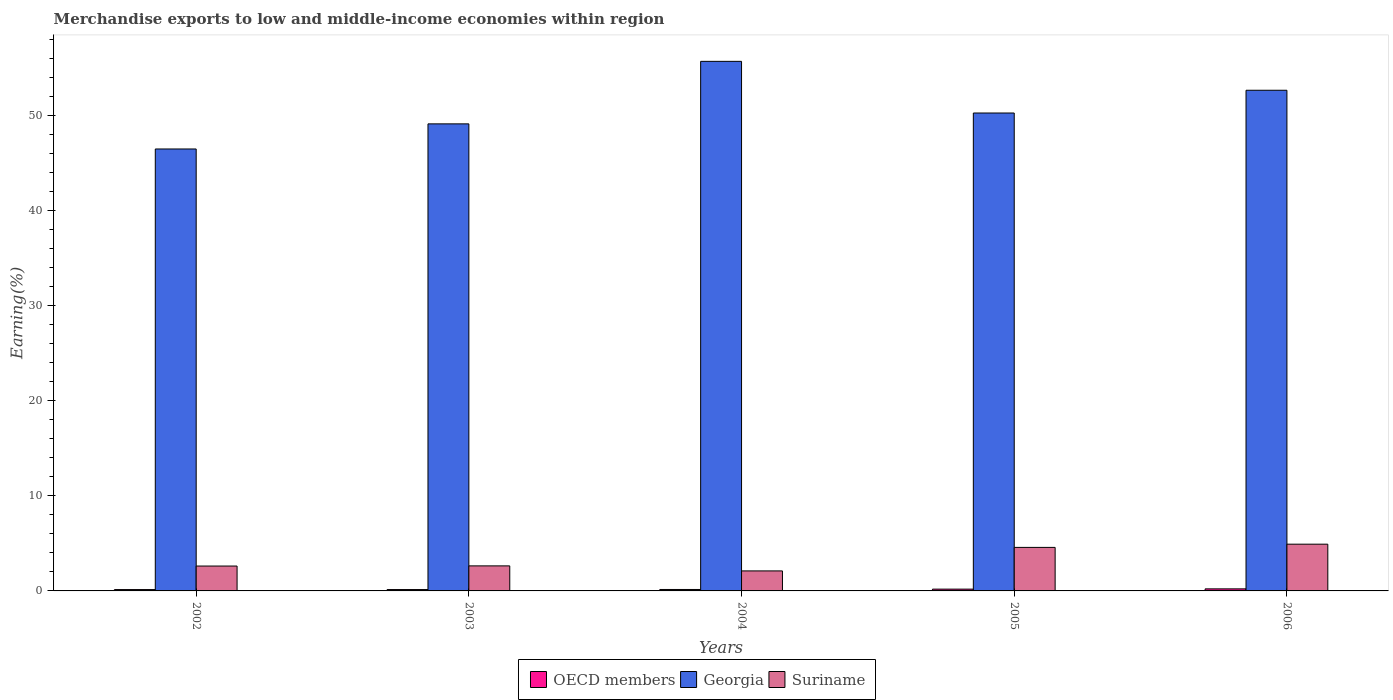Are the number of bars per tick equal to the number of legend labels?
Ensure brevity in your answer.  Yes. What is the percentage of amount earned from merchandise exports in OECD members in 2004?
Offer a terse response. 0.15. Across all years, what is the maximum percentage of amount earned from merchandise exports in Georgia?
Give a very brief answer. 55.66. Across all years, what is the minimum percentage of amount earned from merchandise exports in Georgia?
Your response must be concise. 46.45. In which year was the percentage of amount earned from merchandise exports in Suriname maximum?
Offer a very short reply. 2006. In which year was the percentage of amount earned from merchandise exports in Suriname minimum?
Your response must be concise. 2004. What is the total percentage of amount earned from merchandise exports in OECD members in the graph?
Make the answer very short. 0.84. What is the difference between the percentage of amount earned from merchandise exports in OECD members in 2002 and that in 2003?
Provide a succinct answer. -0. What is the difference between the percentage of amount earned from merchandise exports in Georgia in 2002 and the percentage of amount earned from merchandise exports in Suriname in 2004?
Give a very brief answer. 44.35. What is the average percentage of amount earned from merchandise exports in Suriname per year?
Make the answer very short. 3.37. In the year 2003, what is the difference between the percentage of amount earned from merchandise exports in OECD members and percentage of amount earned from merchandise exports in Suriname?
Ensure brevity in your answer.  -2.49. What is the ratio of the percentage of amount earned from merchandise exports in OECD members in 2002 to that in 2006?
Ensure brevity in your answer.  0.66. What is the difference between the highest and the second highest percentage of amount earned from merchandise exports in OECD members?
Give a very brief answer. 0.03. What is the difference between the highest and the lowest percentage of amount earned from merchandise exports in Suriname?
Offer a terse response. 2.81. In how many years, is the percentage of amount earned from merchandise exports in OECD members greater than the average percentage of amount earned from merchandise exports in OECD members taken over all years?
Your answer should be compact. 2. Is the sum of the percentage of amount earned from merchandise exports in Suriname in 2003 and 2005 greater than the maximum percentage of amount earned from merchandise exports in OECD members across all years?
Keep it short and to the point. Yes. What does the 2nd bar from the left in 2003 represents?
Offer a very short reply. Georgia. How many bars are there?
Offer a very short reply. 15. Are all the bars in the graph horizontal?
Give a very brief answer. No. Does the graph contain any zero values?
Make the answer very short. No. Where does the legend appear in the graph?
Make the answer very short. Bottom center. How many legend labels are there?
Keep it short and to the point. 3. What is the title of the graph?
Your answer should be very brief. Merchandise exports to low and middle-income economies within region. Does "Other small states" appear as one of the legend labels in the graph?
Your response must be concise. No. What is the label or title of the Y-axis?
Your response must be concise. Earning(%). What is the Earning(%) in OECD members in 2002?
Your answer should be very brief. 0.14. What is the Earning(%) in Georgia in 2002?
Ensure brevity in your answer.  46.45. What is the Earning(%) in Suriname in 2002?
Provide a short and direct response. 2.62. What is the Earning(%) of OECD members in 2003?
Keep it short and to the point. 0.14. What is the Earning(%) of Georgia in 2003?
Provide a short and direct response. 49.09. What is the Earning(%) of Suriname in 2003?
Provide a short and direct response. 2.63. What is the Earning(%) in OECD members in 2004?
Keep it short and to the point. 0.15. What is the Earning(%) in Georgia in 2004?
Your response must be concise. 55.66. What is the Earning(%) in Suriname in 2004?
Provide a succinct answer. 2.1. What is the Earning(%) in OECD members in 2005?
Your answer should be compact. 0.19. What is the Earning(%) of Georgia in 2005?
Ensure brevity in your answer.  50.23. What is the Earning(%) of Suriname in 2005?
Offer a terse response. 4.57. What is the Earning(%) of OECD members in 2006?
Your answer should be very brief. 0.22. What is the Earning(%) of Georgia in 2006?
Your response must be concise. 52.62. What is the Earning(%) of Suriname in 2006?
Ensure brevity in your answer.  4.91. Across all years, what is the maximum Earning(%) of OECD members?
Your answer should be very brief. 0.22. Across all years, what is the maximum Earning(%) in Georgia?
Ensure brevity in your answer.  55.66. Across all years, what is the maximum Earning(%) in Suriname?
Your answer should be very brief. 4.91. Across all years, what is the minimum Earning(%) in OECD members?
Your answer should be very brief. 0.14. Across all years, what is the minimum Earning(%) in Georgia?
Offer a terse response. 46.45. Across all years, what is the minimum Earning(%) of Suriname?
Your response must be concise. 2.1. What is the total Earning(%) of OECD members in the graph?
Ensure brevity in your answer.  0.84. What is the total Earning(%) in Georgia in the graph?
Offer a very short reply. 254.06. What is the total Earning(%) in Suriname in the graph?
Offer a terse response. 16.84. What is the difference between the Earning(%) in OECD members in 2002 and that in 2003?
Give a very brief answer. -0. What is the difference between the Earning(%) in Georgia in 2002 and that in 2003?
Keep it short and to the point. -2.64. What is the difference between the Earning(%) in Suriname in 2002 and that in 2003?
Offer a terse response. -0.02. What is the difference between the Earning(%) of OECD members in 2002 and that in 2004?
Your answer should be very brief. -0.01. What is the difference between the Earning(%) of Georgia in 2002 and that in 2004?
Provide a succinct answer. -9.21. What is the difference between the Earning(%) in Suriname in 2002 and that in 2004?
Offer a terse response. 0.51. What is the difference between the Earning(%) in OECD members in 2002 and that in 2005?
Your answer should be very brief. -0.05. What is the difference between the Earning(%) in Georgia in 2002 and that in 2005?
Offer a terse response. -3.78. What is the difference between the Earning(%) of Suriname in 2002 and that in 2005?
Make the answer very short. -1.96. What is the difference between the Earning(%) in OECD members in 2002 and that in 2006?
Keep it short and to the point. -0.07. What is the difference between the Earning(%) of Georgia in 2002 and that in 2006?
Your answer should be very brief. -6.17. What is the difference between the Earning(%) in Suriname in 2002 and that in 2006?
Make the answer very short. -2.3. What is the difference between the Earning(%) in OECD members in 2003 and that in 2004?
Provide a short and direct response. -0.01. What is the difference between the Earning(%) of Georgia in 2003 and that in 2004?
Offer a terse response. -6.57. What is the difference between the Earning(%) of Suriname in 2003 and that in 2004?
Your answer should be compact. 0.53. What is the difference between the Earning(%) of OECD members in 2003 and that in 2005?
Keep it short and to the point. -0.04. What is the difference between the Earning(%) of Georgia in 2003 and that in 2005?
Provide a short and direct response. -1.14. What is the difference between the Earning(%) of Suriname in 2003 and that in 2005?
Ensure brevity in your answer.  -1.94. What is the difference between the Earning(%) of OECD members in 2003 and that in 2006?
Your response must be concise. -0.07. What is the difference between the Earning(%) in Georgia in 2003 and that in 2006?
Offer a terse response. -3.53. What is the difference between the Earning(%) of Suriname in 2003 and that in 2006?
Offer a very short reply. -2.28. What is the difference between the Earning(%) of OECD members in 2004 and that in 2005?
Your answer should be very brief. -0.04. What is the difference between the Earning(%) of Georgia in 2004 and that in 2005?
Provide a short and direct response. 5.43. What is the difference between the Earning(%) in Suriname in 2004 and that in 2005?
Provide a succinct answer. -2.47. What is the difference between the Earning(%) of OECD members in 2004 and that in 2006?
Ensure brevity in your answer.  -0.06. What is the difference between the Earning(%) in Georgia in 2004 and that in 2006?
Make the answer very short. 3.04. What is the difference between the Earning(%) in Suriname in 2004 and that in 2006?
Provide a succinct answer. -2.81. What is the difference between the Earning(%) of OECD members in 2005 and that in 2006?
Your response must be concise. -0.03. What is the difference between the Earning(%) in Georgia in 2005 and that in 2006?
Keep it short and to the point. -2.39. What is the difference between the Earning(%) in Suriname in 2005 and that in 2006?
Your answer should be compact. -0.34. What is the difference between the Earning(%) of OECD members in 2002 and the Earning(%) of Georgia in 2003?
Your answer should be very brief. -48.95. What is the difference between the Earning(%) in OECD members in 2002 and the Earning(%) in Suriname in 2003?
Give a very brief answer. -2.49. What is the difference between the Earning(%) of Georgia in 2002 and the Earning(%) of Suriname in 2003?
Provide a succinct answer. 43.82. What is the difference between the Earning(%) of OECD members in 2002 and the Earning(%) of Georgia in 2004?
Provide a short and direct response. -55.52. What is the difference between the Earning(%) in OECD members in 2002 and the Earning(%) in Suriname in 2004?
Offer a terse response. -1.96. What is the difference between the Earning(%) in Georgia in 2002 and the Earning(%) in Suriname in 2004?
Provide a short and direct response. 44.35. What is the difference between the Earning(%) of OECD members in 2002 and the Earning(%) of Georgia in 2005?
Provide a short and direct response. -50.09. What is the difference between the Earning(%) of OECD members in 2002 and the Earning(%) of Suriname in 2005?
Provide a short and direct response. -4.43. What is the difference between the Earning(%) of Georgia in 2002 and the Earning(%) of Suriname in 2005?
Offer a very short reply. 41.88. What is the difference between the Earning(%) in OECD members in 2002 and the Earning(%) in Georgia in 2006?
Offer a terse response. -52.48. What is the difference between the Earning(%) in OECD members in 2002 and the Earning(%) in Suriname in 2006?
Your answer should be compact. -4.77. What is the difference between the Earning(%) in Georgia in 2002 and the Earning(%) in Suriname in 2006?
Offer a terse response. 41.54. What is the difference between the Earning(%) of OECD members in 2003 and the Earning(%) of Georgia in 2004?
Give a very brief answer. -55.52. What is the difference between the Earning(%) of OECD members in 2003 and the Earning(%) of Suriname in 2004?
Offer a terse response. -1.96. What is the difference between the Earning(%) in Georgia in 2003 and the Earning(%) in Suriname in 2004?
Ensure brevity in your answer.  46.99. What is the difference between the Earning(%) of OECD members in 2003 and the Earning(%) of Georgia in 2005?
Provide a succinct answer. -50.09. What is the difference between the Earning(%) of OECD members in 2003 and the Earning(%) of Suriname in 2005?
Your answer should be very brief. -4.43. What is the difference between the Earning(%) in Georgia in 2003 and the Earning(%) in Suriname in 2005?
Provide a short and direct response. 44.52. What is the difference between the Earning(%) of OECD members in 2003 and the Earning(%) of Georgia in 2006?
Provide a short and direct response. -52.48. What is the difference between the Earning(%) of OECD members in 2003 and the Earning(%) of Suriname in 2006?
Make the answer very short. -4.77. What is the difference between the Earning(%) of Georgia in 2003 and the Earning(%) of Suriname in 2006?
Keep it short and to the point. 44.18. What is the difference between the Earning(%) in OECD members in 2004 and the Earning(%) in Georgia in 2005?
Provide a succinct answer. -50.08. What is the difference between the Earning(%) in OECD members in 2004 and the Earning(%) in Suriname in 2005?
Offer a very short reply. -4.42. What is the difference between the Earning(%) in Georgia in 2004 and the Earning(%) in Suriname in 2005?
Your answer should be very brief. 51.09. What is the difference between the Earning(%) in OECD members in 2004 and the Earning(%) in Georgia in 2006?
Ensure brevity in your answer.  -52.47. What is the difference between the Earning(%) in OECD members in 2004 and the Earning(%) in Suriname in 2006?
Give a very brief answer. -4.76. What is the difference between the Earning(%) in Georgia in 2004 and the Earning(%) in Suriname in 2006?
Make the answer very short. 50.75. What is the difference between the Earning(%) of OECD members in 2005 and the Earning(%) of Georgia in 2006?
Your response must be concise. -52.43. What is the difference between the Earning(%) of OECD members in 2005 and the Earning(%) of Suriname in 2006?
Make the answer very short. -4.72. What is the difference between the Earning(%) of Georgia in 2005 and the Earning(%) of Suriname in 2006?
Keep it short and to the point. 45.32. What is the average Earning(%) of OECD members per year?
Offer a very short reply. 0.17. What is the average Earning(%) of Georgia per year?
Your response must be concise. 50.81. What is the average Earning(%) in Suriname per year?
Your answer should be compact. 3.37. In the year 2002, what is the difference between the Earning(%) in OECD members and Earning(%) in Georgia?
Your answer should be compact. -46.31. In the year 2002, what is the difference between the Earning(%) in OECD members and Earning(%) in Suriname?
Give a very brief answer. -2.47. In the year 2002, what is the difference between the Earning(%) of Georgia and Earning(%) of Suriname?
Make the answer very short. 43.84. In the year 2003, what is the difference between the Earning(%) of OECD members and Earning(%) of Georgia?
Your answer should be compact. -48.95. In the year 2003, what is the difference between the Earning(%) of OECD members and Earning(%) of Suriname?
Keep it short and to the point. -2.49. In the year 2003, what is the difference between the Earning(%) in Georgia and Earning(%) in Suriname?
Provide a short and direct response. 46.46. In the year 2004, what is the difference between the Earning(%) in OECD members and Earning(%) in Georgia?
Make the answer very short. -55.51. In the year 2004, what is the difference between the Earning(%) in OECD members and Earning(%) in Suriname?
Your answer should be very brief. -1.95. In the year 2004, what is the difference between the Earning(%) of Georgia and Earning(%) of Suriname?
Offer a very short reply. 53.56. In the year 2005, what is the difference between the Earning(%) of OECD members and Earning(%) of Georgia?
Make the answer very short. -50.04. In the year 2005, what is the difference between the Earning(%) of OECD members and Earning(%) of Suriname?
Your response must be concise. -4.39. In the year 2005, what is the difference between the Earning(%) of Georgia and Earning(%) of Suriname?
Provide a short and direct response. 45.66. In the year 2006, what is the difference between the Earning(%) in OECD members and Earning(%) in Georgia?
Provide a succinct answer. -52.41. In the year 2006, what is the difference between the Earning(%) in OECD members and Earning(%) in Suriname?
Give a very brief answer. -4.7. In the year 2006, what is the difference between the Earning(%) of Georgia and Earning(%) of Suriname?
Provide a succinct answer. 47.71. What is the ratio of the Earning(%) of OECD members in 2002 to that in 2003?
Make the answer very short. 0.99. What is the ratio of the Earning(%) of Georgia in 2002 to that in 2003?
Your response must be concise. 0.95. What is the ratio of the Earning(%) in OECD members in 2002 to that in 2004?
Ensure brevity in your answer.  0.93. What is the ratio of the Earning(%) in Georgia in 2002 to that in 2004?
Offer a terse response. 0.83. What is the ratio of the Earning(%) of Suriname in 2002 to that in 2004?
Your answer should be very brief. 1.24. What is the ratio of the Earning(%) of OECD members in 2002 to that in 2005?
Ensure brevity in your answer.  0.76. What is the ratio of the Earning(%) in Georgia in 2002 to that in 2005?
Your answer should be very brief. 0.92. What is the ratio of the Earning(%) in Suriname in 2002 to that in 2005?
Make the answer very short. 0.57. What is the ratio of the Earning(%) of OECD members in 2002 to that in 2006?
Make the answer very short. 0.66. What is the ratio of the Earning(%) of Georgia in 2002 to that in 2006?
Provide a short and direct response. 0.88. What is the ratio of the Earning(%) of Suriname in 2002 to that in 2006?
Your response must be concise. 0.53. What is the ratio of the Earning(%) in OECD members in 2003 to that in 2004?
Your answer should be very brief. 0.94. What is the ratio of the Earning(%) of Georgia in 2003 to that in 2004?
Offer a very short reply. 0.88. What is the ratio of the Earning(%) of Suriname in 2003 to that in 2004?
Make the answer very short. 1.25. What is the ratio of the Earning(%) in OECD members in 2003 to that in 2005?
Give a very brief answer. 0.76. What is the ratio of the Earning(%) in Georgia in 2003 to that in 2005?
Give a very brief answer. 0.98. What is the ratio of the Earning(%) in Suriname in 2003 to that in 2005?
Make the answer very short. 0.58. What is the ratio of the Earning(%) of OECD members in 2003 to that in 2006?
Your answer should be very brief. 0.66. What is the ratio of the Earning(%) in Georgia in 2003 to that in 2006?
Offer a very short reply. 0.93. What is the ratio of the Earning(%) of Suriname in 2003 to that in 2006?
Your response must be concise. 0.54. What is the ratio of the Earning(%) in OECD members in 2004 to that in 2005?
Your response must be concise. 0.81. What is the ratio of the Earning(%) in Georgia in 2004 to that in 2005?
Your answer should be very brief. 1.11. What is the ratio of the Earning(%) of Suriname in 2004 to that in 2005?
Offer a very short reply. 0.46. What is the ratio of the Earning(%) in OECD members in 2004 to that in 2006?
Keep it short and to the point. 0.7. What is the ratio of the Earning(%) of Georgia in 2004 to that in 2006?
Keep it short and to the point. 1.06. What is the ratio of the Earning(%) of Suriname in 2004 to that in 2006?
Provide a short and direct response. 0.43. What is the ratio of the Earning(%) in OECD members in 2005 to that in 2006?
Your answer should be very brief. 0.87. What is the ratio of the Earning(%) of Georgia in 2005 to that in 2006?
Keep it short and to the point. 0.95. What is the ratio of the Earning(%) of Suriname in 2005 to that in 2006?
Give a very brief answer. 0.93. What is the difference between the highest and the second highest Earning(%) in OECD members?
Provide a succinct answer. 0.03. What is the difference between the highest and the second highest Earning(%) in Georgia?
Keep it short and to the point. 3.04. What is the difference between the highest and the second highest Earning(%) in Suriname?
Provide a short and direct response. 0.34. What is the difference between the highest and the lowest Earning(%) of OECD members?
Keep it short and to the point. 0.07. What is the difference between the highest and the lowest Earning(%) of Georgia?
Keep it short and to the point. 9.21. What is the difference between the highest and the lowest Earning(%) of Suriname?
Your response must be concise. 2.81. 